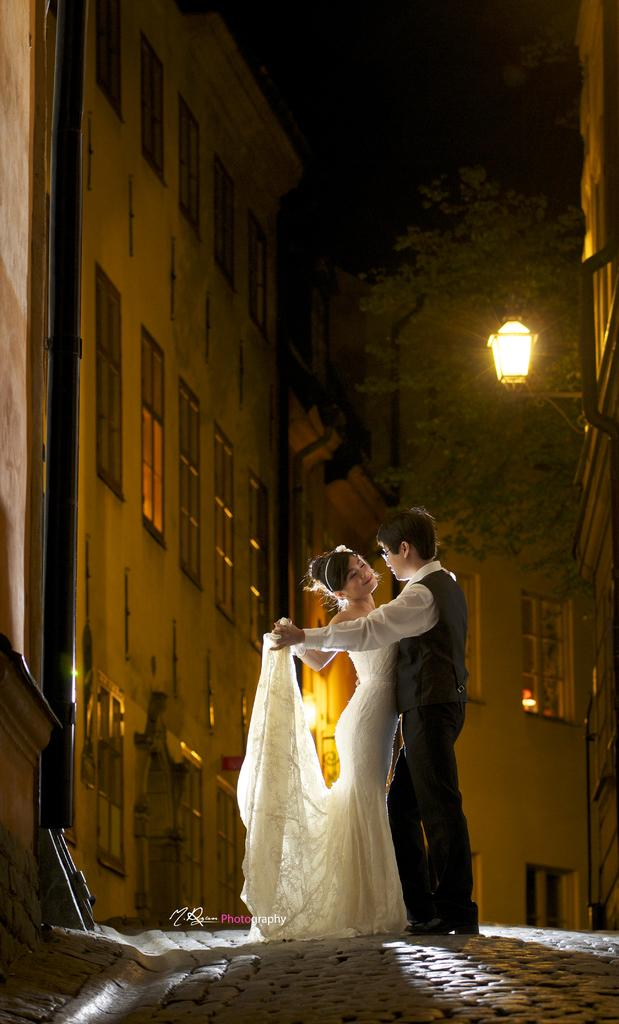How many people are present in the image? There is a man and a woman present in the image. What is the woman wearing in the image? The woman is wearing a white dress in the image. What type of structures can be seen in the image? There are buildings in the image. What other objects can be seen in the image? There is a pipe, trees, and lights visible in the image. What type of dinner is being served in the image? There is no dinner present in the image; it only features a man, a woman, buildings, a pipe, trees, and lights. How does the motion of the lights affect the overall atmosphere in the image? There is no mention of the lights being in motion in the image, so we cannot determine how their motion would affect the atmosphere. 